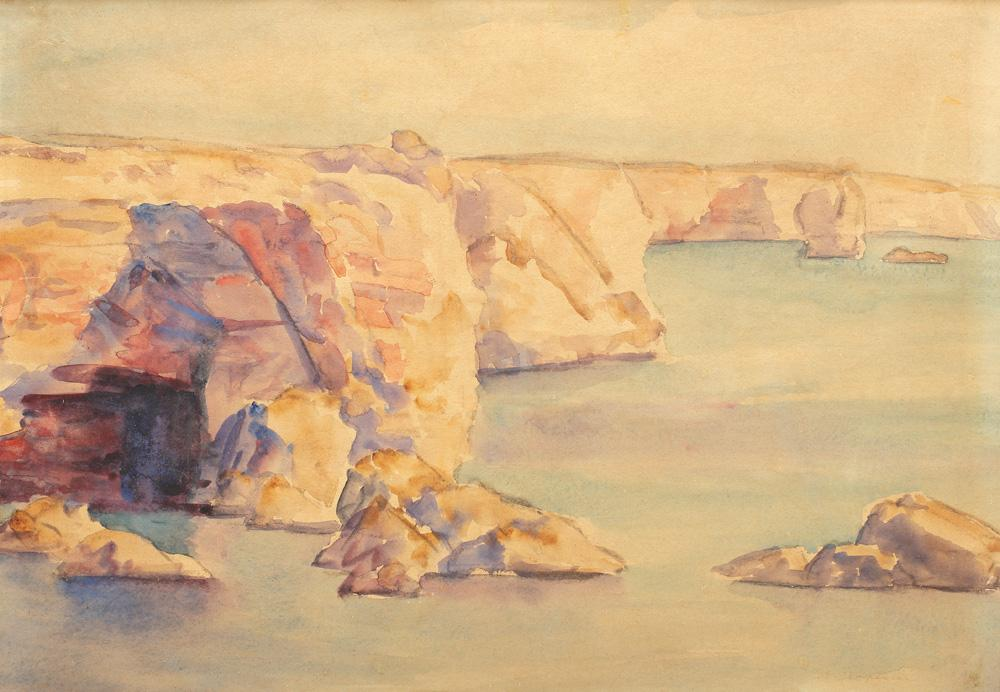What mood does this painting evoke for you? The painting evokes a mood of tranquility and introspection. The warm, soft colors of the cliffs bathed in sunlight suggest warmth and peace, while the calm, cool waters of the sea contribute to a sense of relaxation and serenity. It's a scene that invites you to pause, reflect, and lose yourself in the beauty of nature. Do you think this painting tells any story? Absolutely, this painting can tell a myriad of stories. One might imagine it capturing a quiet, early morning by the sea, where the first light of dawn illuminates the rugged cliffs, revealing their timeless beauty. Perhaps it's a secluded spot known only to a few, a hidden gem that holds countless memories of explorers, artists, and lovers who have found solace and inspiration in its serene embrace. It's a landscape that invites the viewer to imagine their own narrative, adding a personal layer to its inherent beauty. How would this scene change if it were painted at sunset? If this scene were painted at sunset, the mood and colors would shift dramatically. The cliffs might be awash with deep oranges, pinks, and purples as the setting sun casts its final, golden light. Shadows would grow longer and the warm tones would deepen, creating a rich, vibrant palette. The calm waters could reflect a spectrum of rosy hues, enhancing the serenity and beauty of the scene. The atmosphere would be imbued with a sense of closure and peace, capturing a moment of transition between day and night. Imagine if a mythical creature was part of this scene. What would you envision? Incorporating a mythical creature into this scene could add an enchanting, fantastical element. Picture a majestic sea dragon, its scales shimmering with iridescent colors, lazily resting on one of the larger rocky outcrops. Its graceful form blends seamlessly with the jagged cliffs, as if it has always been a part of this ancient landscape. The creature's presence adds a sense of mystery and wonder, suggesting untold stories and legends of the deep seas. The serene nature of the painting contrasts beautifully with the mythical, making the scene both tranquil and magical. Think about a scenario where this place serves as an important location in a historical context. What might that be? In a historical context, this rocky coastline might have served as a pivotal trading post or a hidden pirate cove. Imagine ships laden with precious cargo navigating the calm waters, seeking refuge among the cliffs to trade goods or hide away from pursuing authorities. The cliffs could have provided lookout points, while the secluded coves offered safe havens. Over time, this spot might have accumulated tales of daring rescues, secret transactions, and storied voyages, transforming it from a serene natural wonder into a location steeped in rich maritime history. 